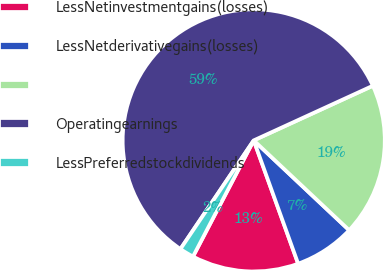Convert chart. <chart><loc_0><loc_0><loc_500><loc_500><pie_chart><fcel>LessNetinvestmentgains(losses)<fcel>LessNetderivativegains(losses)<fcel>Unnamed: 2<fcel>Operatingearnings<fcel>LessPreferredstockdividends<nl><fcel>13.17%<fcel>7.48%<fcel>18.86%<fcel>58.71%<fcel>1.78%<nl></chart> 